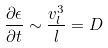<formula> <loc_0><loc_0><loc_500><loc_500>\frac { \partial \epsilon } { \partial { t } } \sim \frac { v _ { l } ^ { 3 } } { l } = D</formula> 